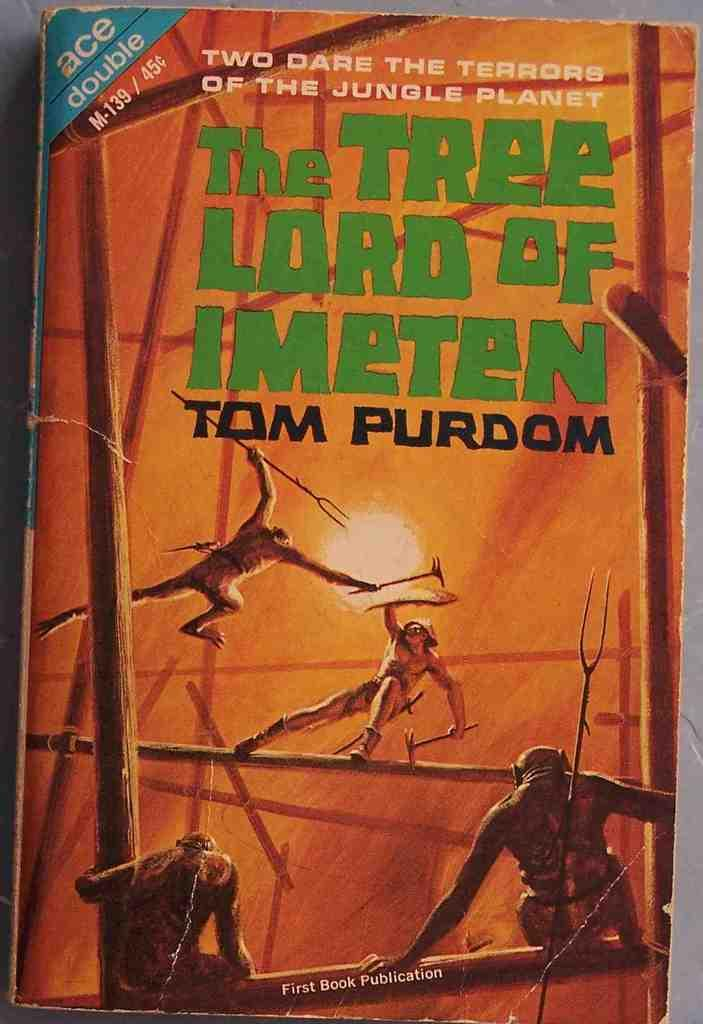<image>
Provide a brief description of the given image. The cover of the book "The Tree Lord of Imeten" by Tom Purdom shows a man fighting apes. 